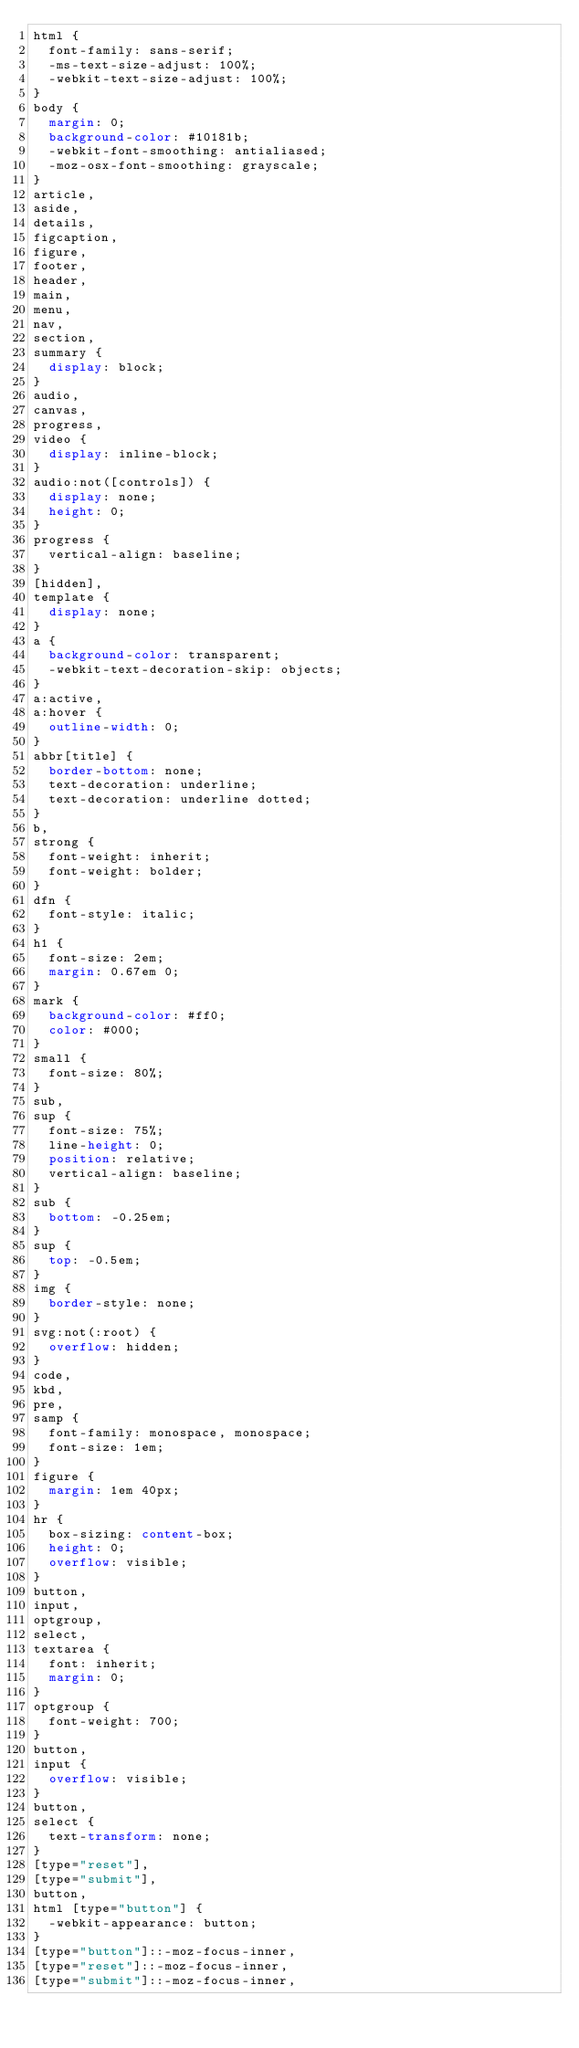<code> <loc_0><loc_0><loc_500><loc_500><_CSS_>html {
  font-family: sans-serif;
  -ms-text-size-adjust: 100%;
  -webkit-text-size-adjust: 100%;
}
body {
  margin: 0;
  background-color: #10181b;
  -webkit-font-smoothing: antialiased;
  -moz-osx-font-smoothing: grayscale;
}
article,
aside,
details,
figcaption,
figure,
footer,
header,
main,
menu,
nav,
section,
summary {
  display: block;
}
audio,
canvas,
progress,
video {
  display: inline-block;
}
audio:not([controls]) {
  display: none;
  height: 0;
}
progress {
  vertical-align: baseline;
}
[hidden],
template {
  display: none;
}
a {
  background-color: transparent;
  -webkit-text-decoration-skip: objects;
}
a:active,
a:hover {
  outline-width: 0;
}
abbr[title] {
  border-bottom: none;
  text-decoration: underline;
  text-decoration: underline dotted;
}
b,
strong {
  font-weight: inherit;
  font-weight: bolder;
}
dfn {
  font-style: italic;
}
h1 {
  font-size: 2em;
  margin: 0.67em 0;
}
mark {
  background-color: #ff0;
  color: #000;
}
small {
  font-size: 80%;
}
sub,
sup {
  font-size: 75%;
  line-height: 0;
  position: relative;
  vertical-align: baseline;
}
sub {
  bottom: -0.25em;
}
sup {
  top: -0.5em;
}
img {
  border-style: none;
}
svg:not(:root) {
  overflow: hidden;
}
code,
kbd,
pre,
samp {
  font-family: monospace, monospace;
  font-size: 1em;
}
figure {
  margin: 1em 40px;
}
hr {
  box-sizing: content-box;
  height: 0;
  overflow: visible;
}
button,
input,
optgroup,
select,
textarea {
  font: inherit;
  margin: 0;
}
optgroup {
  font-weight: 700;
}
button,
input {
  overflow: visible;
}
button,
select {
  text-transform: none;
}
[type="reset"],
[type="submit"],
button,
html [type="button"] {
  -webkit-appearance: button;
}
[type="button"]::-moz-focus-inner,
[type="reset"]::-moz-focus-inner,
[type="submit"]::-moz-focus-inner,</code> 